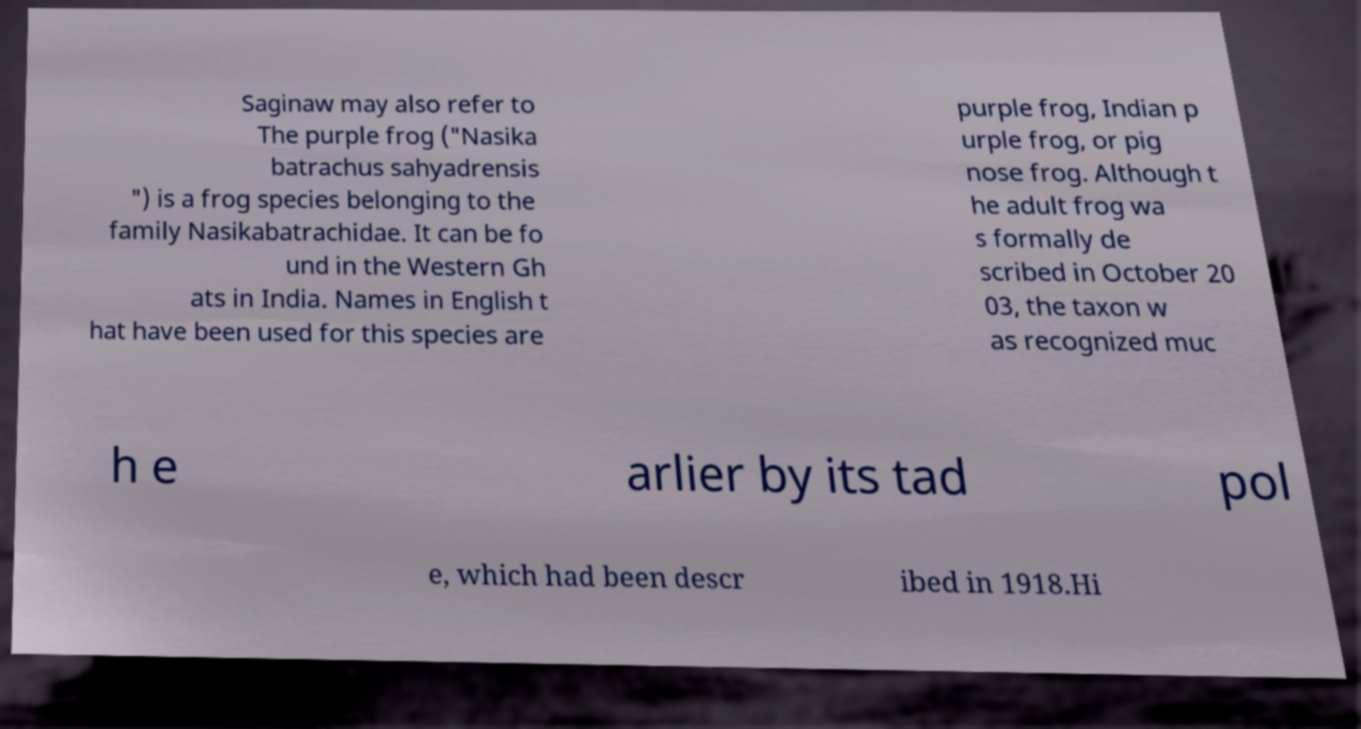Can you read and provide the text displayed in the image?This photo seems to have some interesting text. Can you extract and type it out for me? Saginaw may also refer to The purple frog ("Nasika batrachus sahyadrensis ") is a frog species belonging to the family Nasikabatrachidae. It can be fo und in the Western Gh ats in India. Names in English t hat have been used for this species are purple frog, Indian p urple frog, or pig nose frog. Although t he adult frog wa s formally de scribed in October 20 03, the taxon w as recognized muc h e arlier by its tad pol e, which had been descr ibed in 1918.Hi 